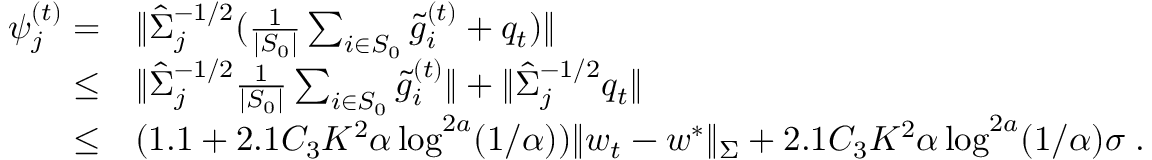Convert formula to latex. <formula><loc_0><loc_0><loc_500><loc_500>\begin{array} { r l } { \psi _ { j } ^ { ( t ) } = } & { \| \hat { \Sigma } _ { j } ^ { - 1 / 2 } ( \frac { 1 } { | S _ { 0 } | } \sum _ { i \in S _ { 0 } } \tilde { g } _ { i } ^ { ( t ) } + q _ { t } ) \| } \\ { \leq } & { \| \hat { \Sigma } _ { j } ^ { - 1 / 2 } \frac { 1 } { | S _ { 0 } | } \sum _ { i \in S _ { 0 } } \tilde { g } _ { i } ^ { ( t ) } \| + \| \hat { \Sigma } _ { j } ^ { - 1 / 2 } q _ { t } \| } \\ { \leq } & { ( 1 . 1 + 2 . 1 C _ { 3 } K ^ { 2 } \alpha \log ^ { 2 a } ( 1 / \alpha ) ) \| w _ { t } - w ^ { * } \| _ { \Sigma } + 2 . 1 C _ { 3 } K ^ { 2 } \alpha \log ^ { 2 a } ( 1 / \alpha ) \sigma \, . } \end{array}</formula> 